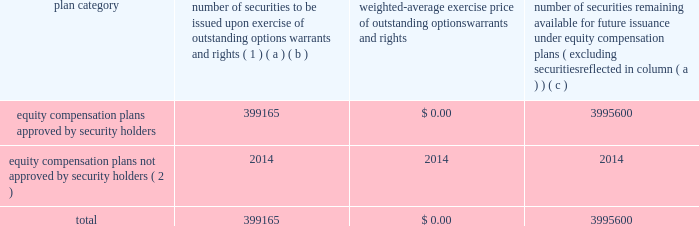Equity compensation plan information the table presents the equity securities available for issuance under our equity compensation plans as of december 31 , 2018 .
Equity compensation plan information plan category number of securities to be issued upon exercise of outstanding options , warrants and rights ( 1 ) weighted-average exercise price of outstanding options , warrants and rights number of securities remaining available for future issuance under equity compensation plans ( excluding securities reflected in column ( a ) ) ( a ) ( b ) ( c ) equity compensation plans approved by security holders 399165 $ 0.00 3995600 equity compensation plans not approved by security holders ( 2 ) 2014 2014 2014 .
( 1 ) includes grants made under the huntington ingalls industries , inc .
2012 long-term incentive stock plan ( the "2012 plan" ) , which was approved by our stockholders on may 2 , 2012 , and the huntington ingalls industries , inc .
2011 long-term incentive stock plan ( the "2011 plan" ) , which was approved by the sole stockholder of hii prior to its spin-off from northrop grumman corporation .
Of these shares , 27123 were stock rights granted under the 2011 plan .
In addition , this number includes 31697 stock rights , 5051 restricted stock rights , and 335293 restricted performance stock rights granted under the 2012 plan , assuming target performance achievement .
( 2 ) there are no awards made under plans not approved by security holders .
Item 13 .
Certain relationships and related transactions , and director independence information as to certain relationships and related transactions and director independence will be incorporated herein by reference to the proxy statement for our 2019 annual meeting of stockholders , to be filed within 120 days after the end of the company 2019s fiscal year .
Item 14 .
Principal accountant fees and services information as to principal accountant fees and services will be incorporated herein by reference to the proxy statement for our 2019 annual meeting of stockholders , to be filed within 120 days after the end of the company 2019s fiscal year. .
As of december 312018 what was the total number of number of securities of the equity compensation plans approved by security holders? 
Computations: (399165 + 3995600)
Answer: 4394765.0. 